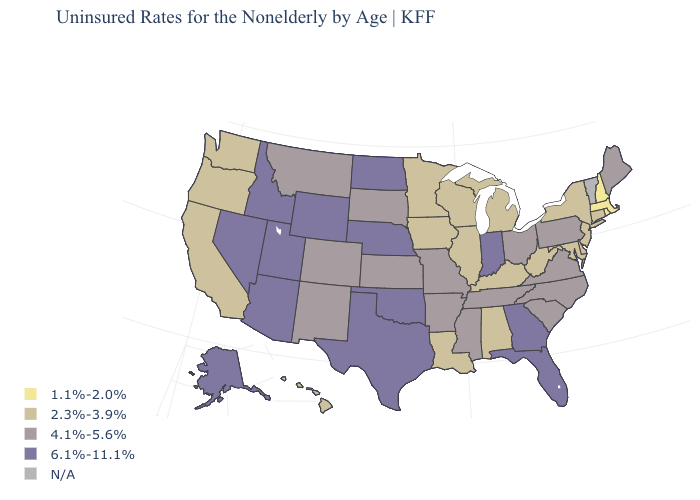What is the value of South Carolina?
Write a very short answer. 4.1%-5.6%. What is the value of Tennessee?
Concise answer only. 4.1%-5.6%. Name the states that have a value in the range 1.1%-2.0%?
Keep it brief. Massachusetts, New Hampshire, Rhode Island. Name the states that have a value in the range 4.1%-5.6%?
Answer briefly. Arkansas, Colorado, Kansas, Maine, Mississippi, Missouri, Montana, New Mexico, North Carolina, Ohio, Pennsylvania, South Carolina, South Dakota, Tennessee, Virginia. Name the states that have a value in the range 2.3%-3.9%?
Answer briefly. Alabama, California, Connecticut, Delaware, Hawaii, Illinois, Iowa, Kentucky, Louisiana, Maryland, Michigan, Minnesota, New Jersey, New York, Oregon, Washington, West Virginia, Wisconsin. Which states have the lowest value in the Northeast?
Quick response, please. Massachusetts, New Hampshire, Rhode Island. Name the states that have a value in the range 6.1%-11.1%?
Write a very short answer. Alaska, Arizona, Florida, Georgia, Idaho, Indiana, Nebraska, Nevada, North Dakota, Oklahoma, Texas, Utah, Wyoming. Does Oregon have the lowest value in the West?
Short answer required. Yes. Name the states that have a value in the range 2.3%-3.9%?
Quick response, please. Alabama, California, Connecticut, Delaware, Hawaii, Illinois, Iowa, Kentucky, Louisiana, Maryland, Michigan, Minnesota, New Jersey, New York, Oregon, Washington, West Virginia, Wisconsin. Name the states that have a value in the range 4.1%-5.6%?
Short answer required. Arkansas, Colorado, Kansas, Maine, Mississippi, Missouri, Montana, New Mexico, North Carolina, Ohio, Pennsylvania, South Carolina, South Dakota, Tennessee, Virginia. Is the legend a continuous bar?
Be succinct. No. What is the value of Connecticut?
Keep it brief. 2.3%-3.9%. Which states have the lowest value in the West?
Give a very brief answer. California, Hawaii, Oregon, Washington. 